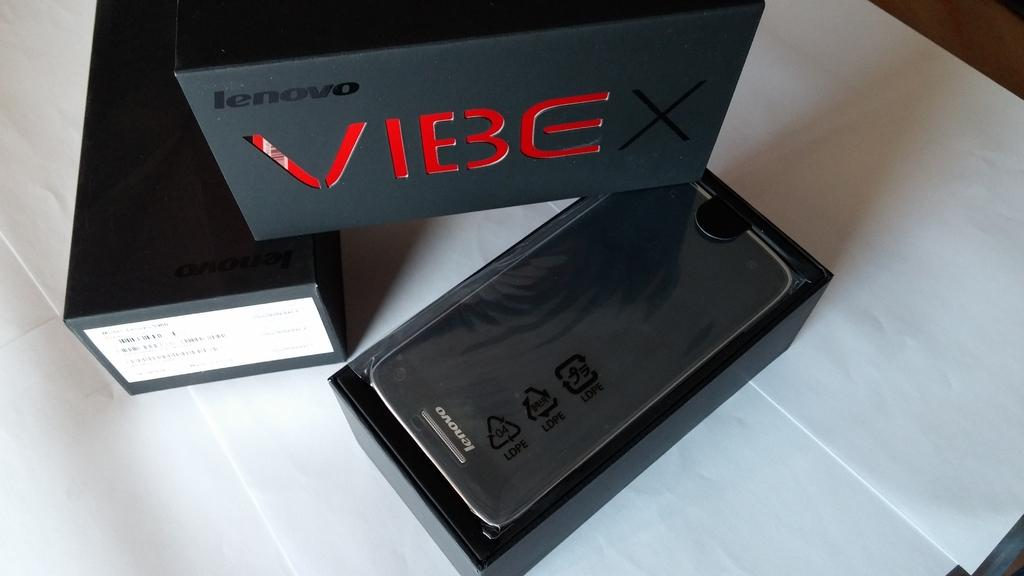<image>
Describe the image concisely. Black box that says VIBE on it next to a phone. 